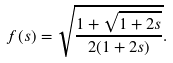Convert formula to latex. <formula><loc_0><loc_0><loc_500><loc_500>f ( s ) = \sqrt { \frac { 1 + \sqrt { 1 + 2 s } } { 2 ( 1 + 2 s ) } } .</formula> 